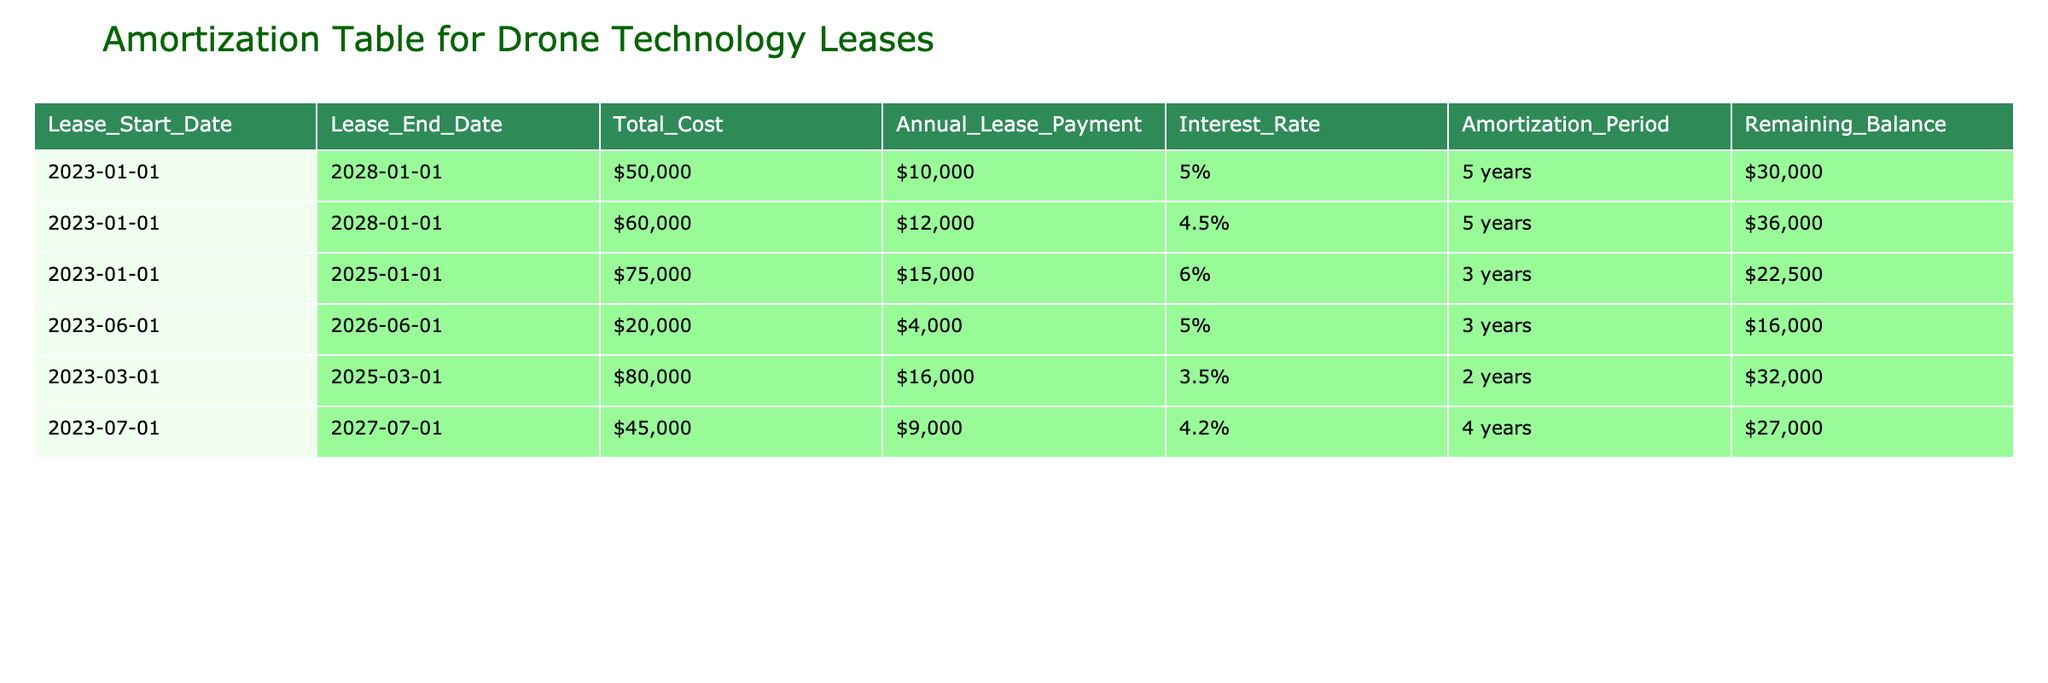What is the total cost of the lease for the drone technology starting on January 1, 2023? In the table, we find two leases starting on January 1, 2023: one for $50,000 and another for $60,000. Adding these amounts together gives us a total cost of $50,000 + $60,000 = $110,000.
Answer: $110,000 Which lease has the highest annual lease payment? By looking at the annual lease payment column, we see that the lease with the highest payment is for $16,000, which corresponds to the lease starting on March 1, 2023.
Answer: $16,000 Is the remaining balance for the lease ending on January 1, 2025 greater than $20,000? The lease that ends on January 1, 2025 has a remaining balance of $32,000. Since $32,000 is greater than $20,000, the answer is yes.
Answer: Yes What is the average remaining balance of all leases? To find the average, we first add up all the remaining balances: $30,000 + $36,000 + $22,500 + $16,000 + $32,000 + $27,000 = $163,500. There are 6 leases, so the average is $163,500 / 6 = $27,250.
Answer: $27,250 Do any leases have an amortization period of 3 years? By checking the amortization period column, we see that there are three leases with an amortization period of 3 years. Therefore, the answer is yes.
Answer: Yes What would be the total cost of leases with an interest rate less than 5%? The leases with interest rates less than 5% are two: one for $60,000 with a 4.5% rate and another for $80,000 with a 3.5% rate. Adding these costs gives $60,000 + $80,000 = $140,000.
Answer: $140,000 If we combine the annual lease payments for leases ending in 2025, what is the total? The leases ending in 2025 have annual payments of $15,000 (for the lease starting on January 1, 2023) and $16,000 (for the lease starting on March 1, 2023). Adding these amounts gives $15,000 + $16,000 = $31,000.
Answer: $31,000 Which lease has the least remaining balance? Checking the remaining balance column, we see that the lease with the least remaining balance is the one ending on June 1, 2026, which has a remaining balance of $16,000.
Answer: $16,000 What is the difference between the total cost of the lease starting June 1, 2023, and the lease ending January 1, 2025? The lease starting on June 1, 2023, costs $20,000, while the lease ending on January 1, 2025, costs $75,000. The difference is calculated as $75,000 - $20,000 = $55,000.
Answer: $55,000 